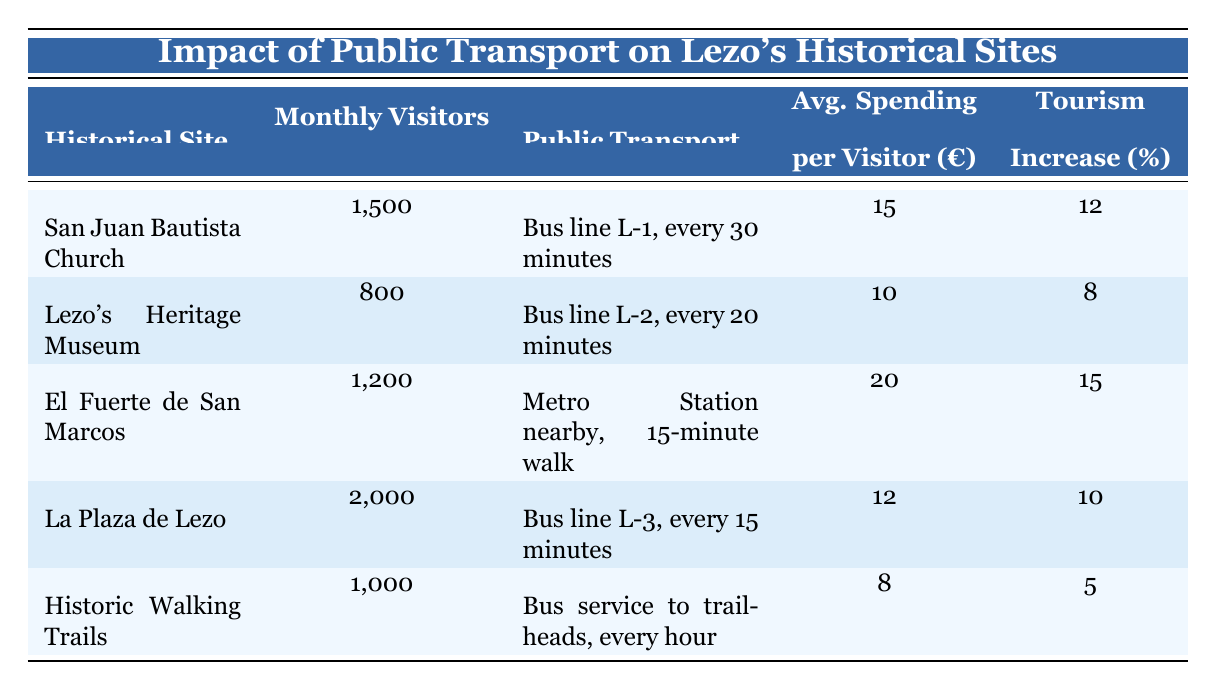What is the total number of monthly visitors across all historical sites in Lezo? To find the total number of monthly visitors, sum the monthly visitors for each site: 1500 (San Juan Bautista Church) + 800 (Lezo's Heritage Museum) + 1200 (El Fuerte de San Marcos) + 2000 (La Plaza de Lezo) + 1000 (Historic Walking Trails) = 5500 visitors.
Answer: 5500 Which historical site has the highest average spending per visitor? By comparing the average spending per visitor across the sites, San Juan Bautista Church has €15, Lezo's Heritage Museum has €10, El Fuerte de San Marcos has €20, La Plaza de Lezo has €12, and Historic Walking Trails has €8. The highest is €20 at El Fuerte de San Marcos.
Answer: El Fuerte de San Marcos Is the tourism increase percentage for La Plaza de Lezo greater than the average for all sites? First, calculate the average tourism increase percentage: (12 + 8 + 15 + 10 + 5) / 5 = 10%. La Plaza de Lezo has a tourism increase of 10%, which is equal but not greater than the average.
Answer: No What is the total average spending for visitors across all historical sites? The average spending per visitor for each site is: €15 (San Juan Bautista Church), €10 (Lezo's Heritage Museum), €20 (El Fuerte de San Marcos), €12 (La Plaza de Lezo), €8 (Historic Walking Trails). Total is €15 + €10 + €20 + €12 + €8 = €75 and divide by 5 sites, giving an average of €15.
Answer: €15 Does every historical site have access to public transport? Each site is listed with specific public transport options: San Juan Bautista Church has Bus line L-1, Lezo's Heritage Museum has Bus line L-2, El Fuerte de San Marcos has a nearby metro station, La Plaza de Lezo has Bus line L-3, and Historic Walking Trails has a bus service. Therefore, all sites have public transport access.
Answer: Yes Which historical site experienced the lowest tourism increase percentage? The tourism increase percentages are: 12% (San Juan Bautista Church), 8% (Lezo's Heritage Museum), 15% (El Fuerte de San Marcos), 10% (La Plaza de Lezo), and 5% (Historic Walking Trails). The lowest is 5%.
Answer: Historic Walking Trails What is the relationship between public transport accessibility frequency and monthly visitors for the historical sites? The frequency of public transport for sites with monthly visitors is as follows: San Juan Bautista Church (1500) with every 30 minutes, Lezo's Heritage Museum (800) every 20 minutes, El Fuerte de San Marcos (1200) a 15-minute walk, La Plaza de Lezo (2000) every 15 minutes, and Historic Walking Trails (1000) every hour. Generally, shorter wait times (such as those of La Plaza de Lezo and El Fuerte de San Marcos) correlate with higher visitors.
Answer: The shorter the frequency of transport, the more visitors typically observed at those sites 